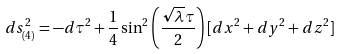Convert formula to latex. <formula><loc_0><loc_0><loc_500><loc_500>d s _ { ( 4 ) } ^ { 2 } = - d \tau ^ { 2 } + \frac { 1 } { 4 } \sin ^ { 2 } \left ( \frac { \sqrt { \lambda } \tau } { 2 } \right ) [ d x ^ { 2 } + d y ^ { 2 } + d z ^ { 2 } ]</formula> 